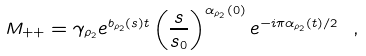<formula> <loc_0><loc_0><loc_500><loc_500>M _ { + + } = \gamma _ { \rho _ { 2 } } e ^ { b _ { \rho _ { 2 } } ( s ) t } \left ( \frac { s } { s _ { 0 } } \right ) ^ { \alpha _ { \rho _ { 2 } } ( 0 ) } e ^ { - i \pi \alpha _ { \rho _ { 2 } } ( t ) / 2 } \ ,</formula> 